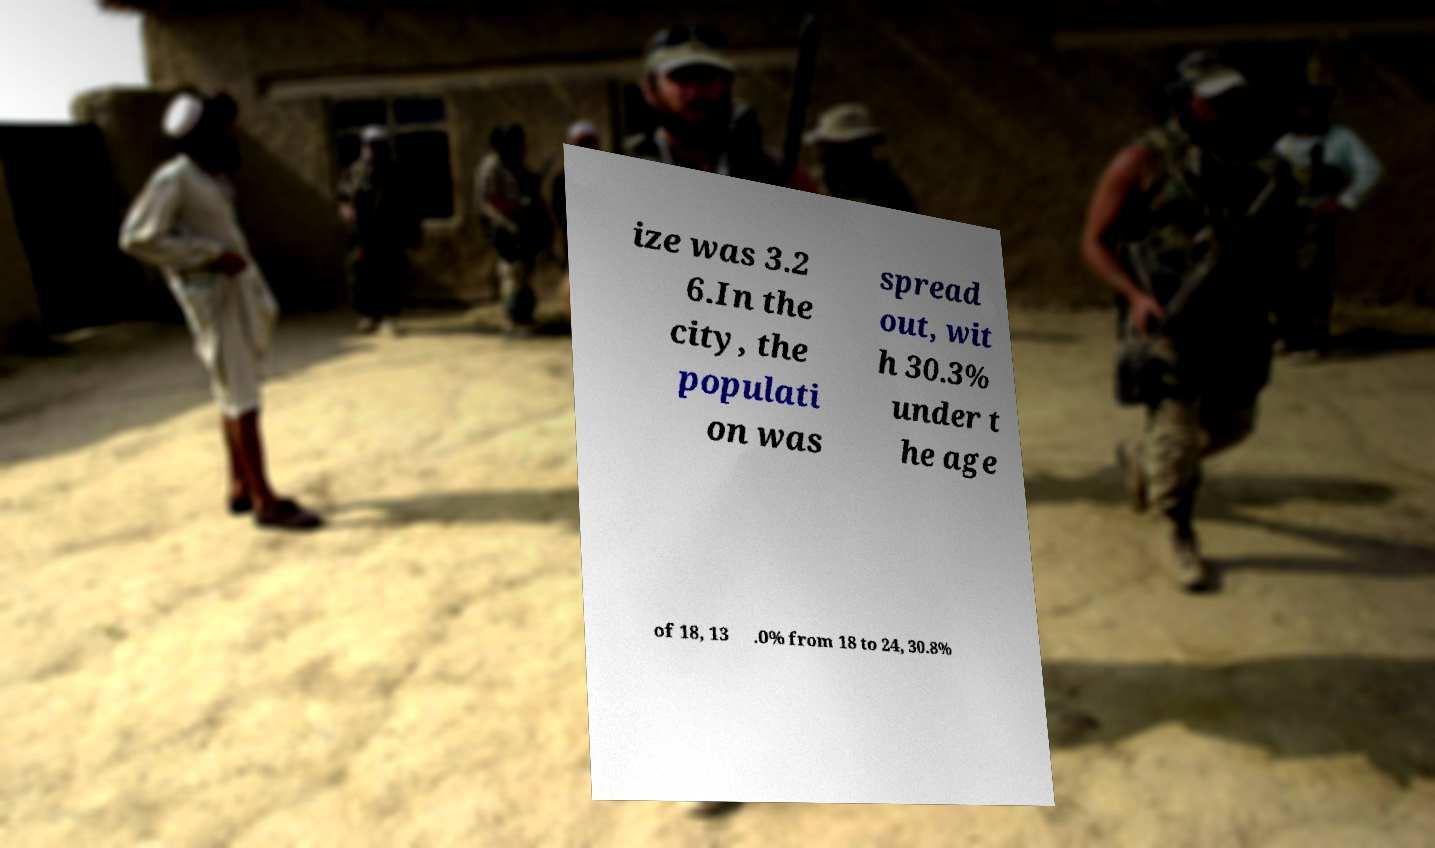Can you accurately transcribe the text from the provided image for me? ize was 3.2 6.In the city, the populati on was spread out, wit h 30.3% under t he age of 18, 13 .0% from 18 to 24, 30.8% 